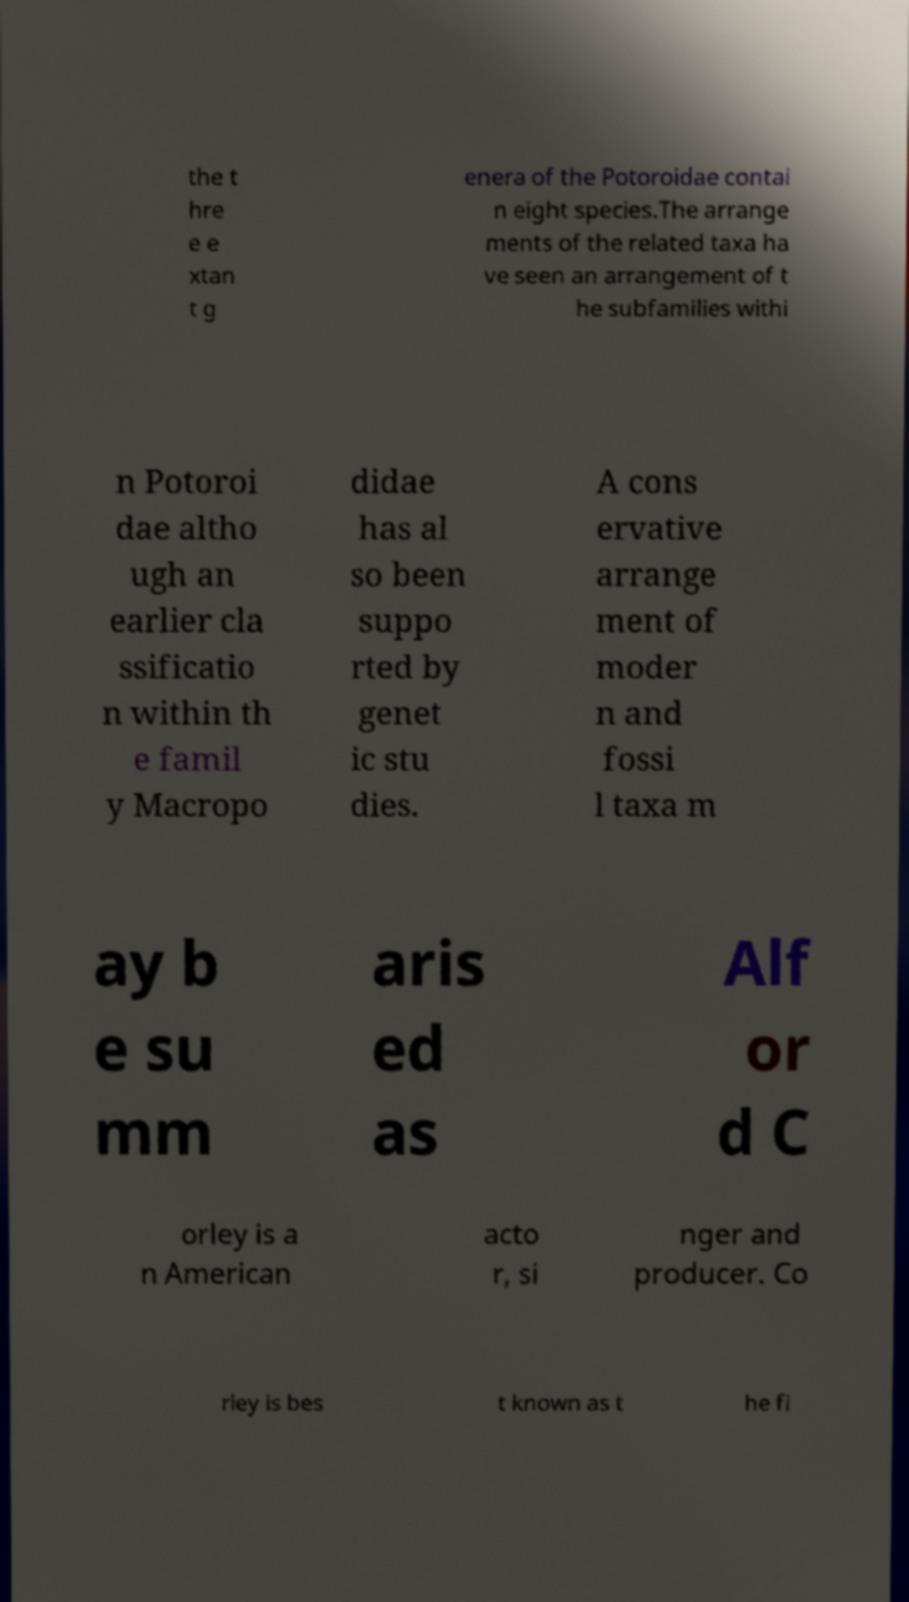Please read and relay the text visible in this image. What does it say? the t hre e e xtan t g enera of the Potoroidae contai n eight species.The arrange ments of the related taxa ha ve seen an arrangement of t he subfamilies withi n Potoroi dae altho ugh an earlier cla ssificatio n within th e famil y Macropo didae has al so been suppo rted by genet ic stu dies. A cons ervative arrange ment of moder n and fossi l taxa m ay b e su mm aris ed as Alf or d C orley is a n American acto r, si nger and producer. Co rley is bes t known as t he fi 